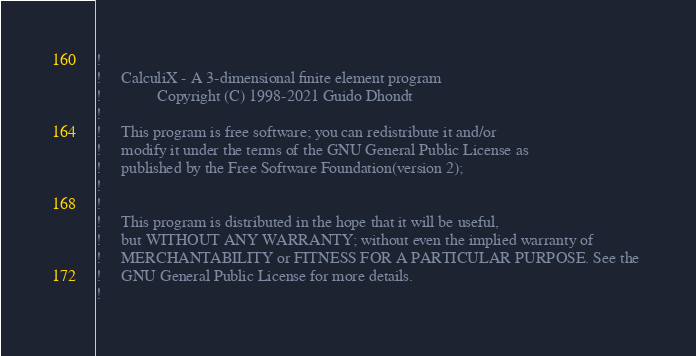Convert code to text. <code><loc_0><loc_0><loc_500><loc_500><_FORTRAN_>!
!     CalculiX - A 3-dimensional finite element program
!              Copyright (C) 1998-2021 Guido Dhondt
!
!     This program is free software; you can redistribute it and/or
!     modify it under the terms of the GNU General Public License as
!     published by the Free Software Foundation(version 2);
!     
!
!     This program is distributed in the hope that it will be useful,
!     but WITHOUT ANY WARRANTY; without even the implied warranty of 
!     MERCHANTABILITY or FITNESS FOR A PARTICULAR PURPOSE. See the 
!     GNU General Public License for more details.
!</code> 